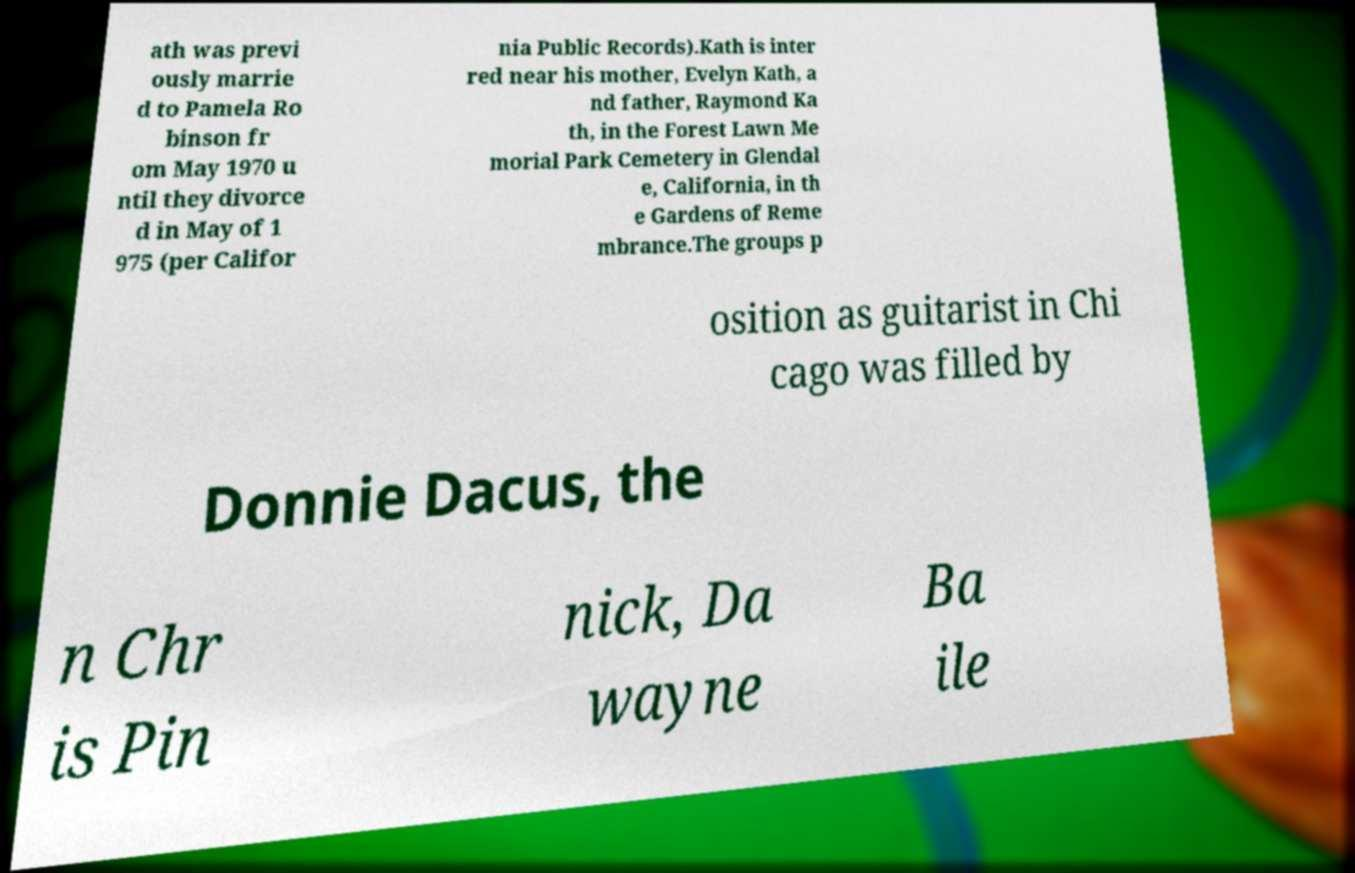What messages or text are displayed in this image? I need them in a readable, typed format. ath was previ ously marrie d to Pamela Ro binson fr om May 1970 u ntil they divorce d in May of 1 975 (per Califor nia Public Records).Kath is inter red near his mother, Evelyn Kath, a nd father, Raymond Ka th, in the Forest Lawn Me morial Park Cemetery in Glendal e, California, in th e Gardens of Reme mbrance.The groups p osition as guitarist in Chi cago was filled by Donnie Dacus, the n Chr is Pin nick, Da wayne Ba ile 